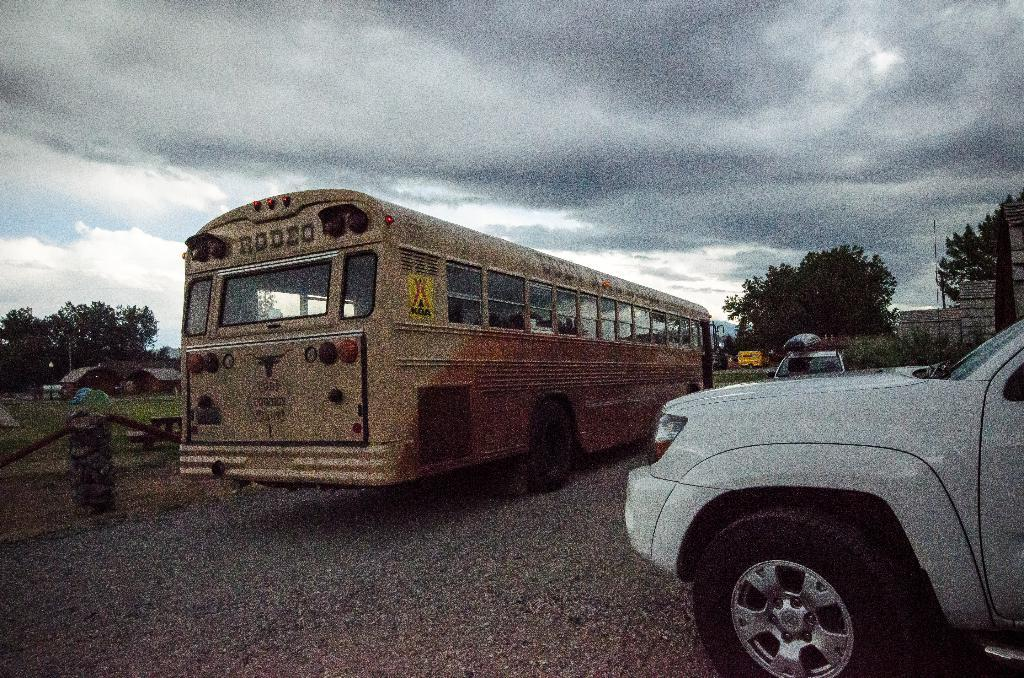<image>
Relay a brief, clear account of the picture shown. The bus is from the local rodeo in Cody 